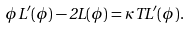Convert formula to latex. <formula><loc_0><loc_0><loc_500><loc_500>\phi L ^ { \prime } ( \phi ) - 2 L ( \phi ) = \kappa T L ^ { \prime } ( \phi ) .</formula> 